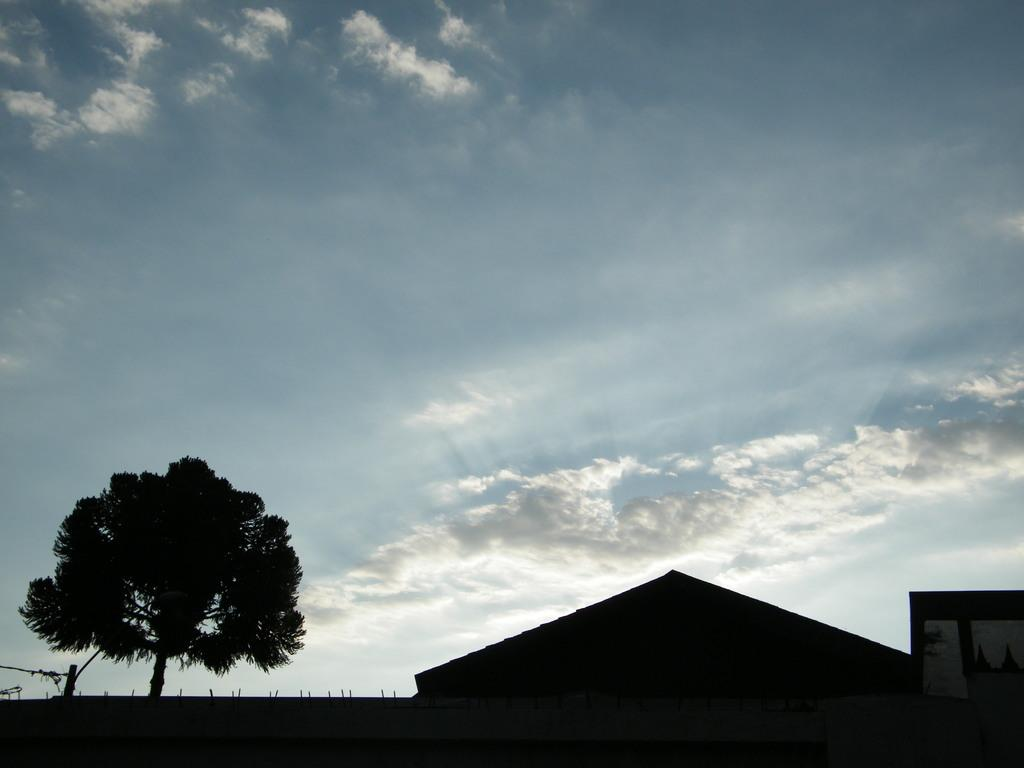What type of building is present in the image? There is a house in the image. What other natural element can be seen in the image? There is a tree in the image. What is visible in the background of the image? The sky is visible in the background of the image. What type of bomb is present in the image? There is no bomb present in the image; it features a house and a tree with the sky visible in the background. 